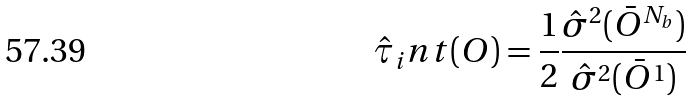Convert formula to latex. <formula><loc_0><loc_0><loc_500><loc_500>\hat { \tau } _ { i } n t ( O ) = \frac { 1 } { 2 } \frac { \hat { \sigma } ^ { 2 } ( \bar { O } ^ { N _ { b } } ) } { \hat { \sigma } ^ { 2 } ( \bar { O } ^ { 1 } ) }</formula> 